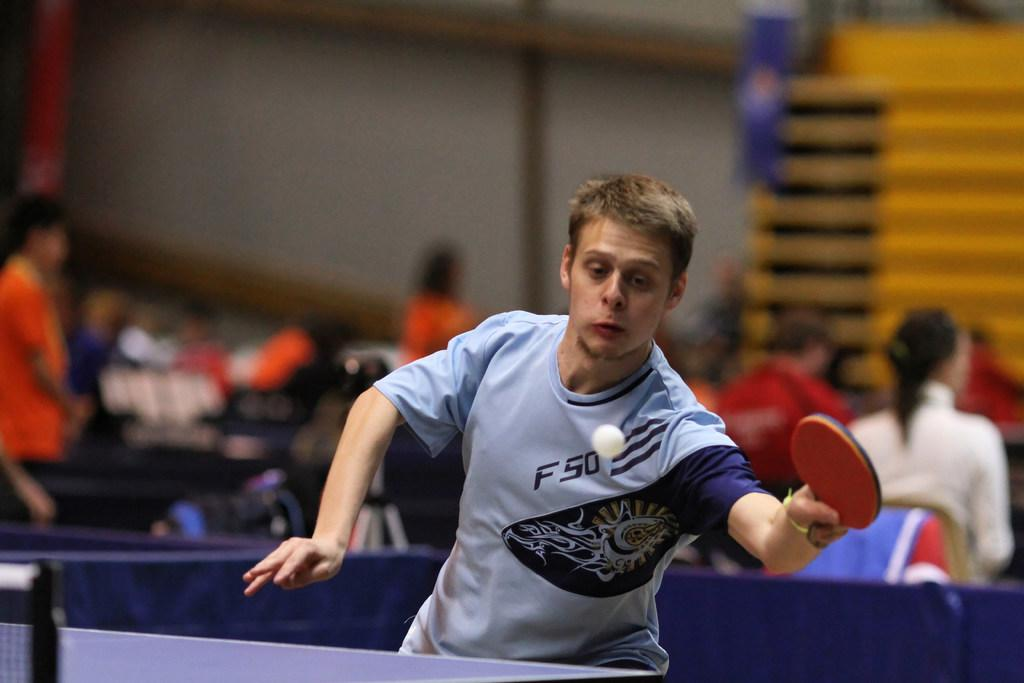<image>
Share a concise interpretation of the image provided. A man is about to hit a ball with a paddle and has the letter f on his shirt. 